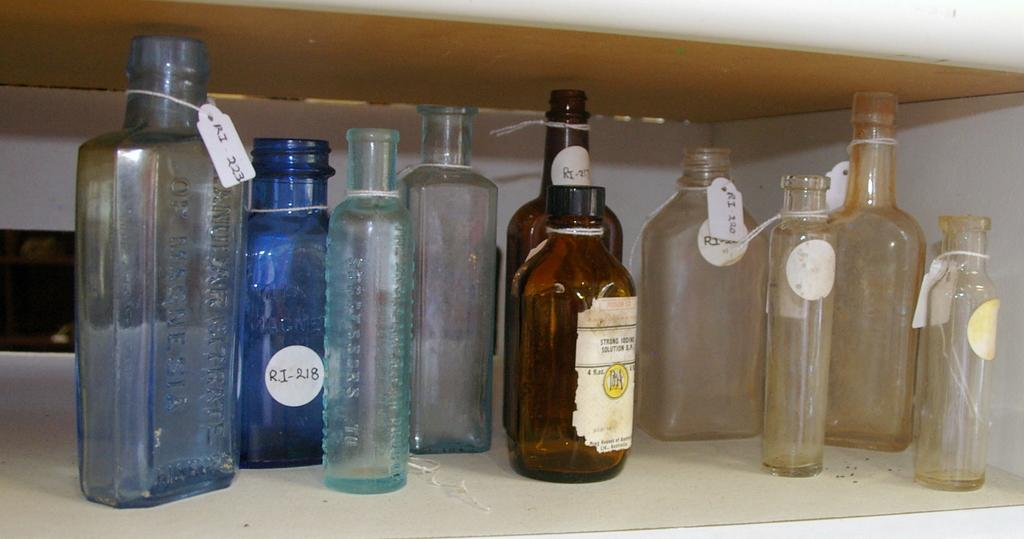Provide a one-sentence caption for the provided image. a blue bottle with RJ 18 on it. 